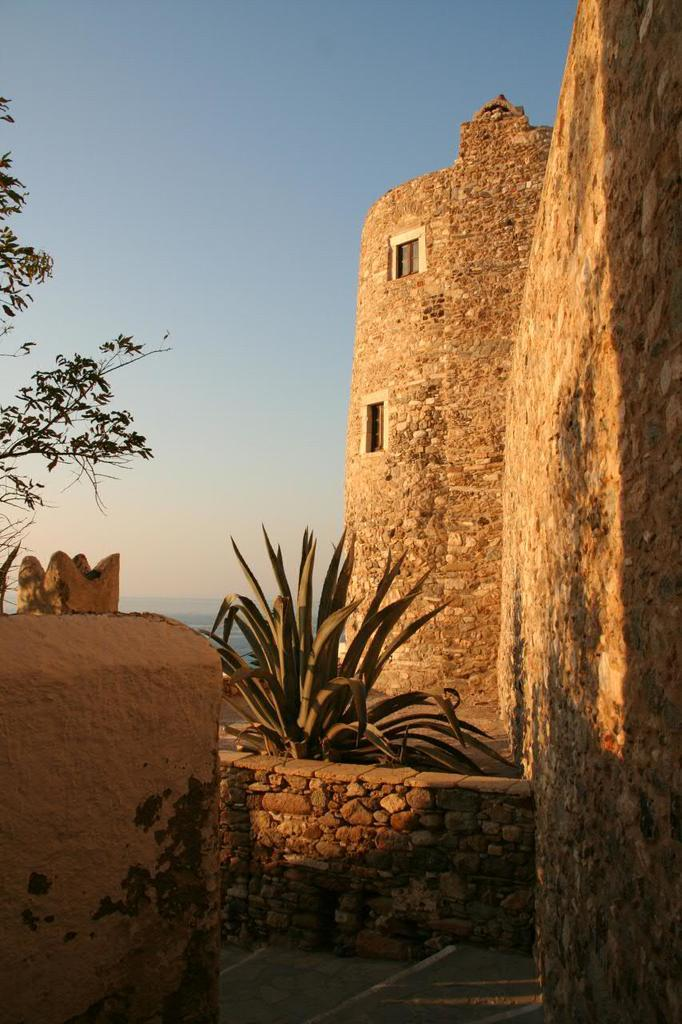What type of structure is visible in the image? There is a stone structure in the image. What feature can be seen on the stone structure? The stone structure has windows. What other elements are present in the image besides the stone structure? There are plants and a tree on the left side of the image. What can be seen in the background of the image? The sky is visible in the background of the image. How does the stone structure change its color throughout the day in the image? The image does not depict any changes in the color of the stone structure throughout the day, as it is a static image. 